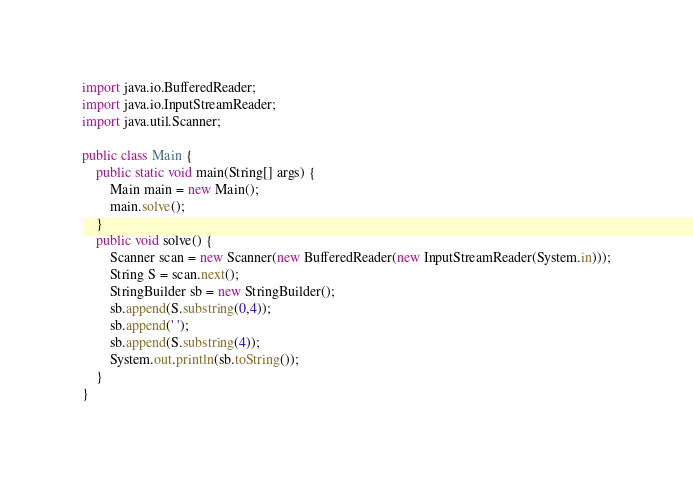<code> <loc_0><loc_0><loc_500><loc_500><_Java_>import java.io.BufferedReader;
import java.io.InputStreamReader;
import java.util.Scanner;

public class Main {
    public static void main(String[] args) {
        Main main = new Main();
        main.solve();
    }
    public void solve() {
        Scanner scan = new Scanner(new BufferedReader(new InputStreamReader(System.in)));
        String S = scan.next();
        StringBuilder sb = new StringBuilder();
        sb.append(S.substring(0,4));
        sb.append(' ');
        sb.append(S.substring(4));
        System.out.println(sb.toString());
    }
}
</code> 